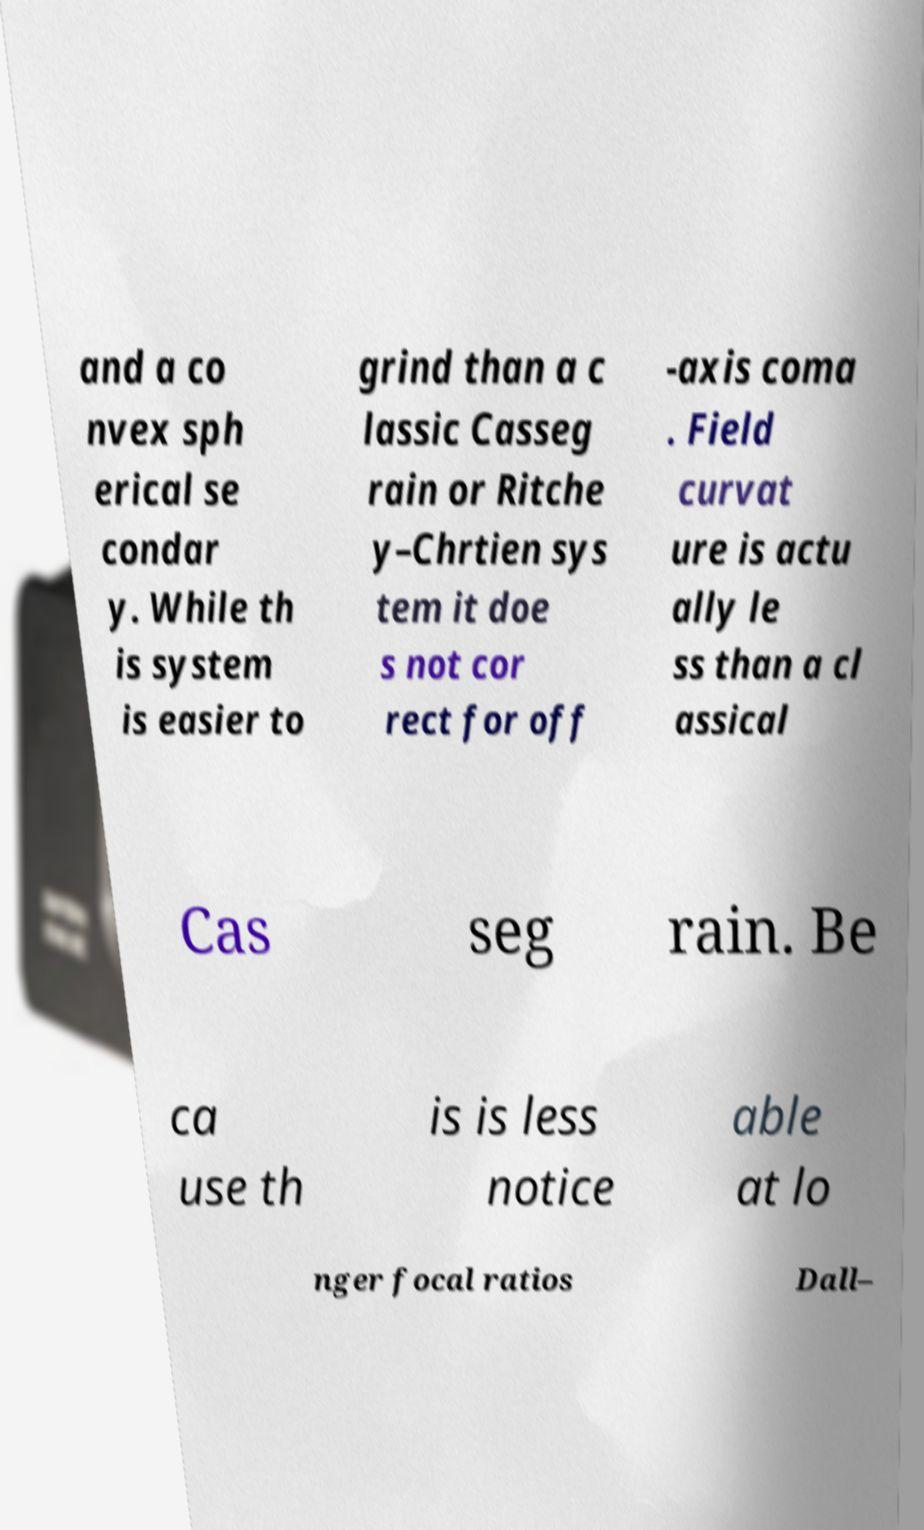What messages or text are displayed in this image? I need them in a readable, typed format. and a co nvex sph erical se condar y. While th is system is easier to grind than a c lassic Casseg rain or Ritche y–Chrtien sys tem it doe s not cor rect for off -axis coma . Field curvat ure is actu ally le ss than a cl assical Cas seg rain. Be ca use th is is less notice able at lo nger focal ratios Dall– 